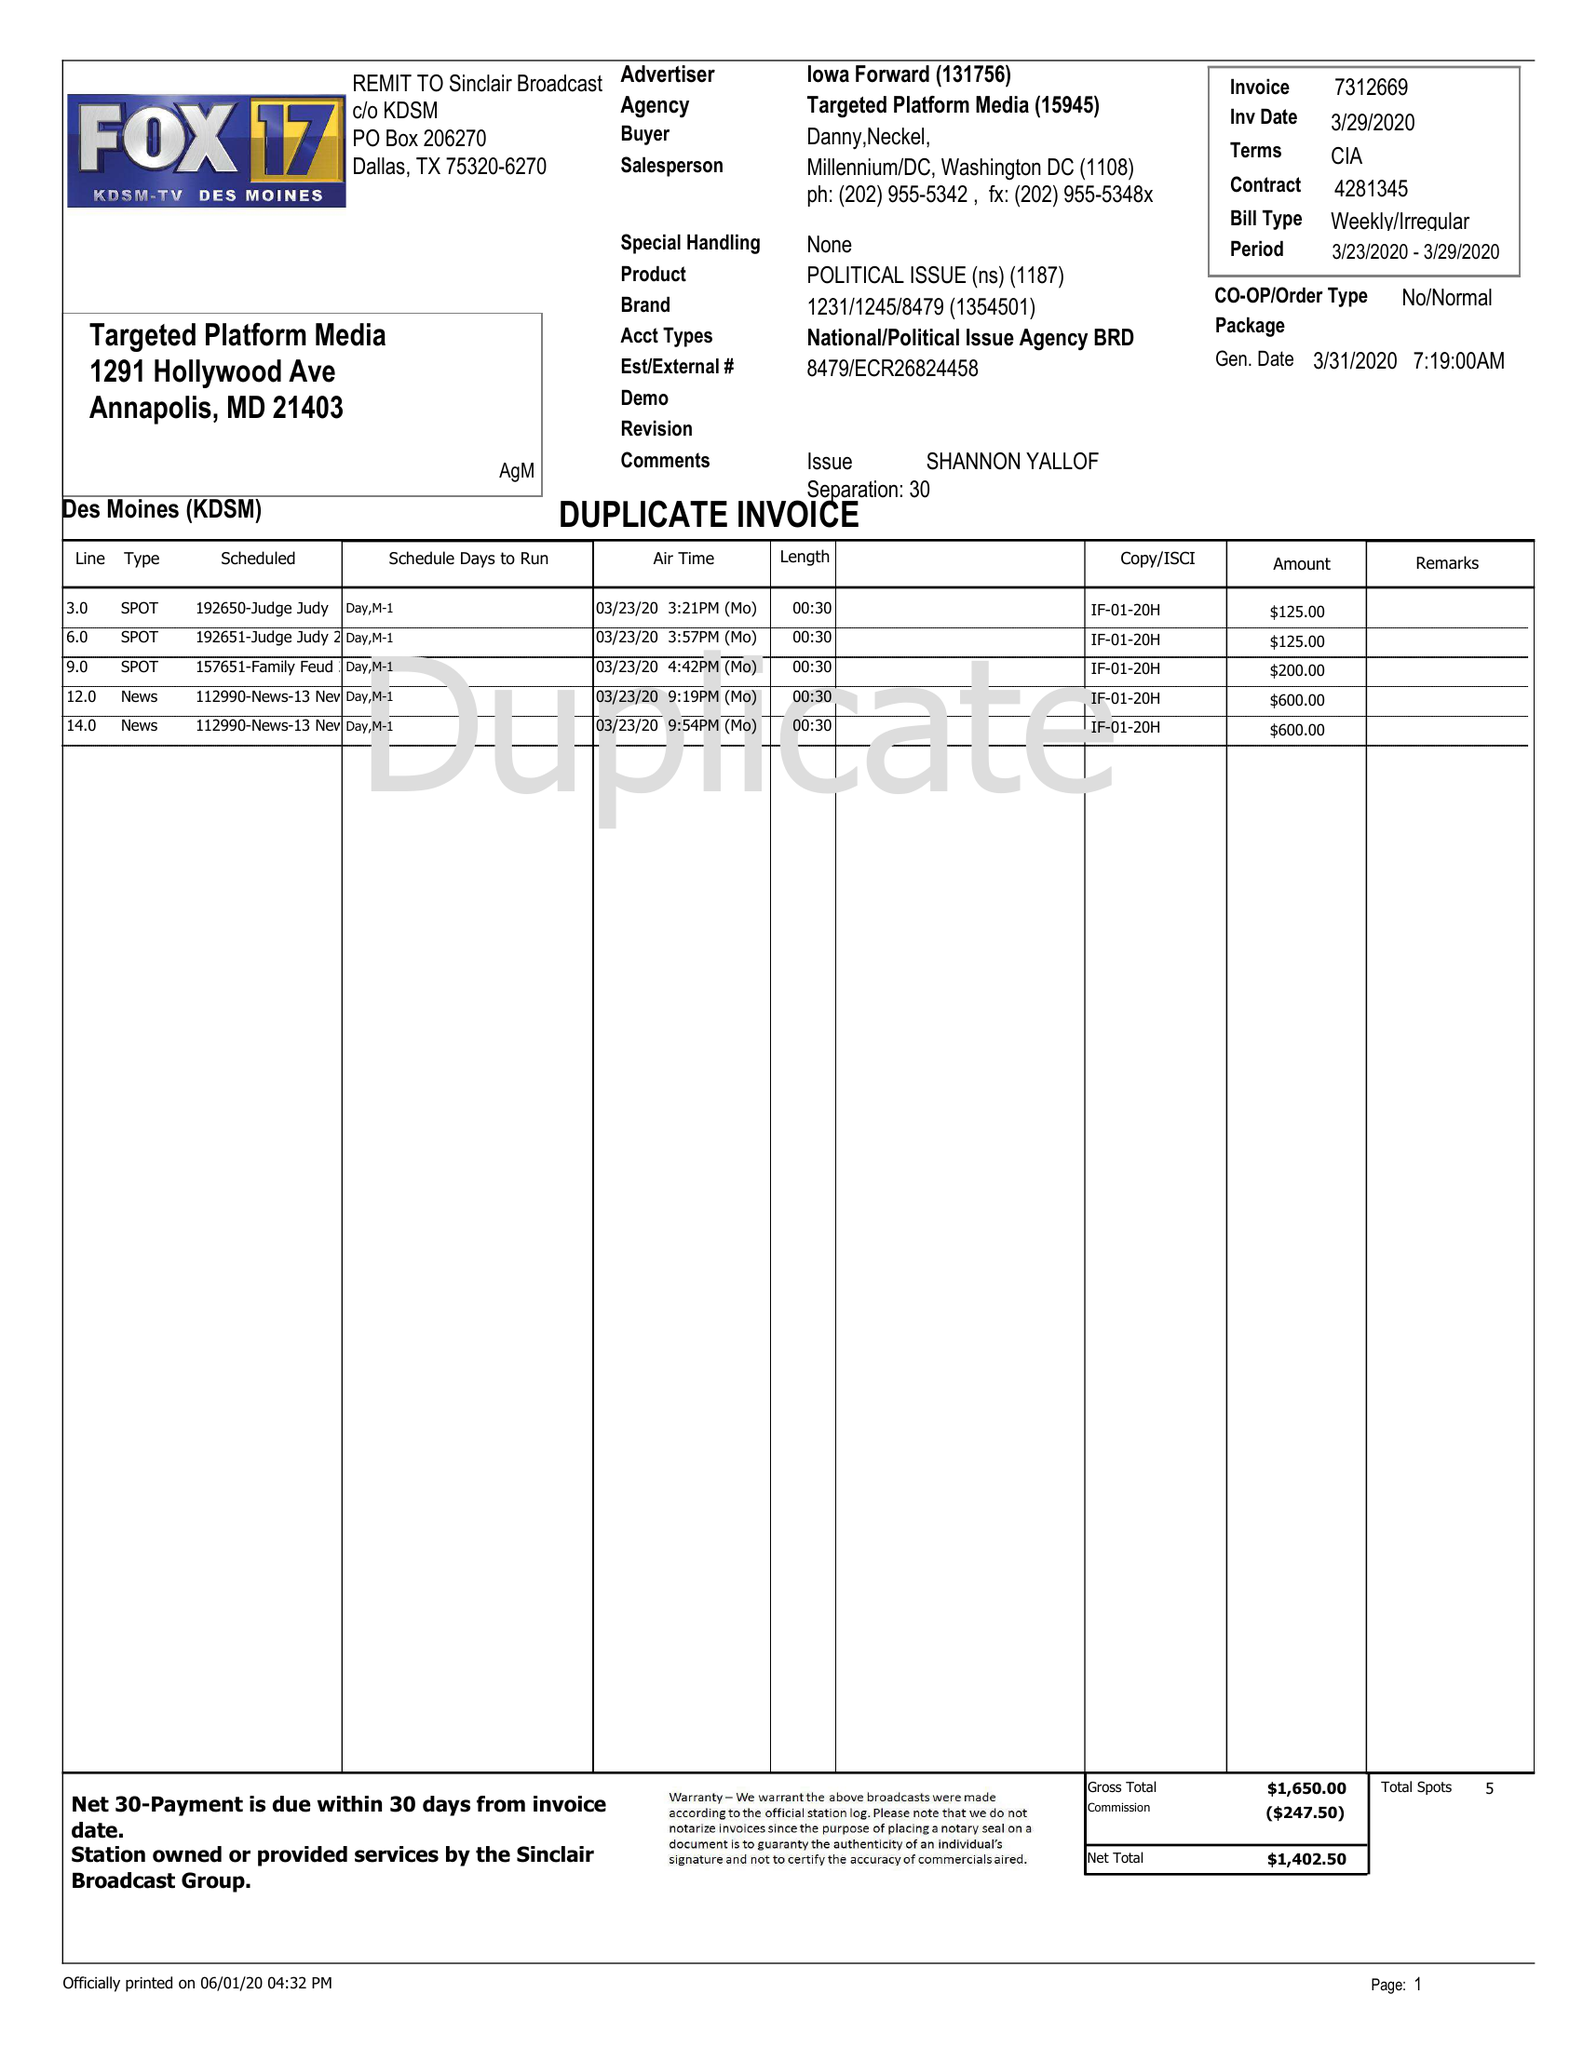What is the value for the flight_from?
Answer the question using a single word or phrase. 03/23/20 